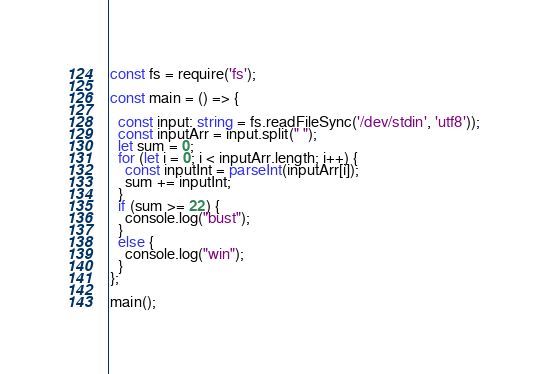<code> <loc_0><loc_0><loc_500><loc_500><_TypeScript_>const fs = require('fs');

const main = () => {
  
  const input: string = fs.readFileSync('/dev/stdin', 'utf8'));
  const inputArr = input.split(" ");
  let sum = 0;
  for (let i = 0; i < inputArr.length; i++) {
    const inputInt = parseInt(inputArr[i]);
    sum += inputInt;
  }
  if (sum >= 22) {
    console.log("bust");
  }
  else {
    console.log("win");
  }
};

main();</code> 